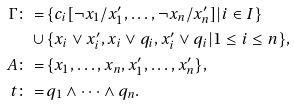Convert formula to latex. <formula><loc_0><loc_0><loc_500><loc_500>\Gamma \colon = \, & \{ c _ { i } [ \neg x _ { 1 } / x ^ { \prime } _ { 1 } , \dots , \neg x _ { n } / x ^ { \prime } _ { n } ] | i \in I \} \\ \cup \, & \{ x _ { i } \lor x ^ { \prime } _ { i } , x _ { i } \lor q _ { i } , x ^ { \prime } _ { i } \lor q _ { i } | 1 \leq i \leq n \} , \\ A \colon = \, & \{ x _ { 1 } , \dots , x _ { n } , x ^ { \prime } _ { 1 } , \dots , x ^ { \prime } _ { n } \} , \\ t \colon = \, & q _ { 1 } \land \cdots \land q _ { n } .</formula> 